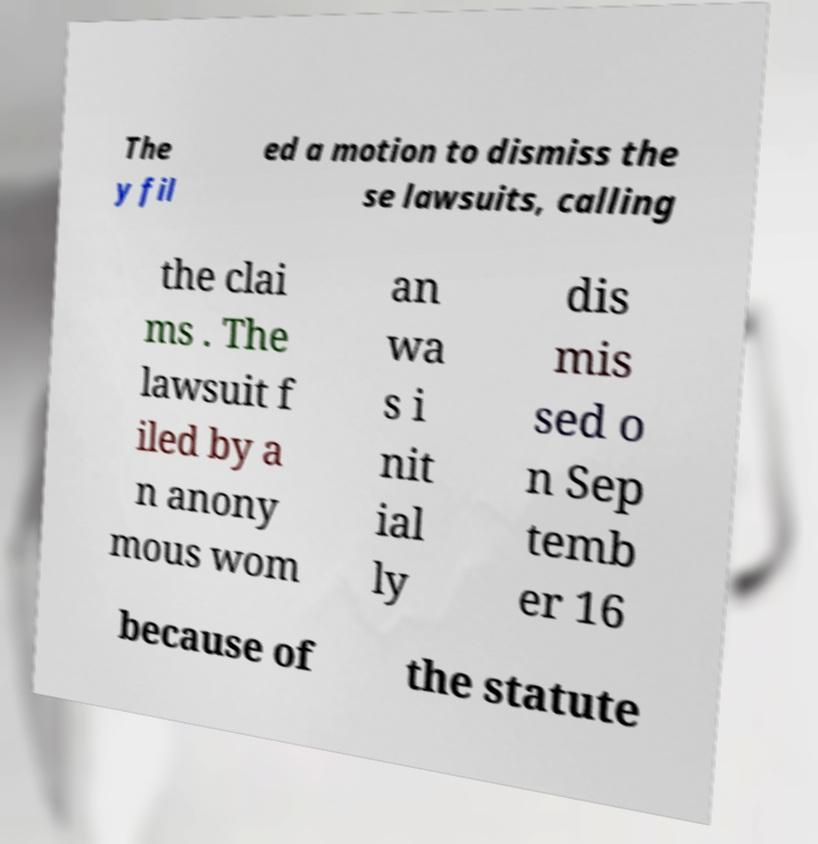Can you read and provide the text displayed in the image?This photo seems to have some interesting text. Can you extract and type it out for me? The y fil ed a motion to dismiss the se lawsuits, calling the clai ms . The lawsuit f iled by a n anony mous wom an wa s i nit ial ly dis mis sed o n Sep temb er 16 because of the statute 